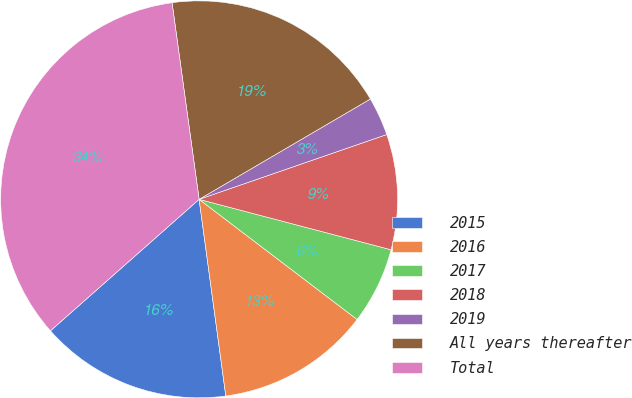Convert chart to OTSL. <chart><loc_0><loc_0><loc_500><loc_500><pie_chart><fcel>2015<fcel>2016<fcel>2017<fcel>2018<fcel>2019<fcel>All years thereafter<fcel>Total<nl><fcel>15.62%<fcel>12.5%<fcel>6.26%<fcel>9.38%<fcel>3.14%<fcel>18.74%<fcel>34.34%<nl></chart> 